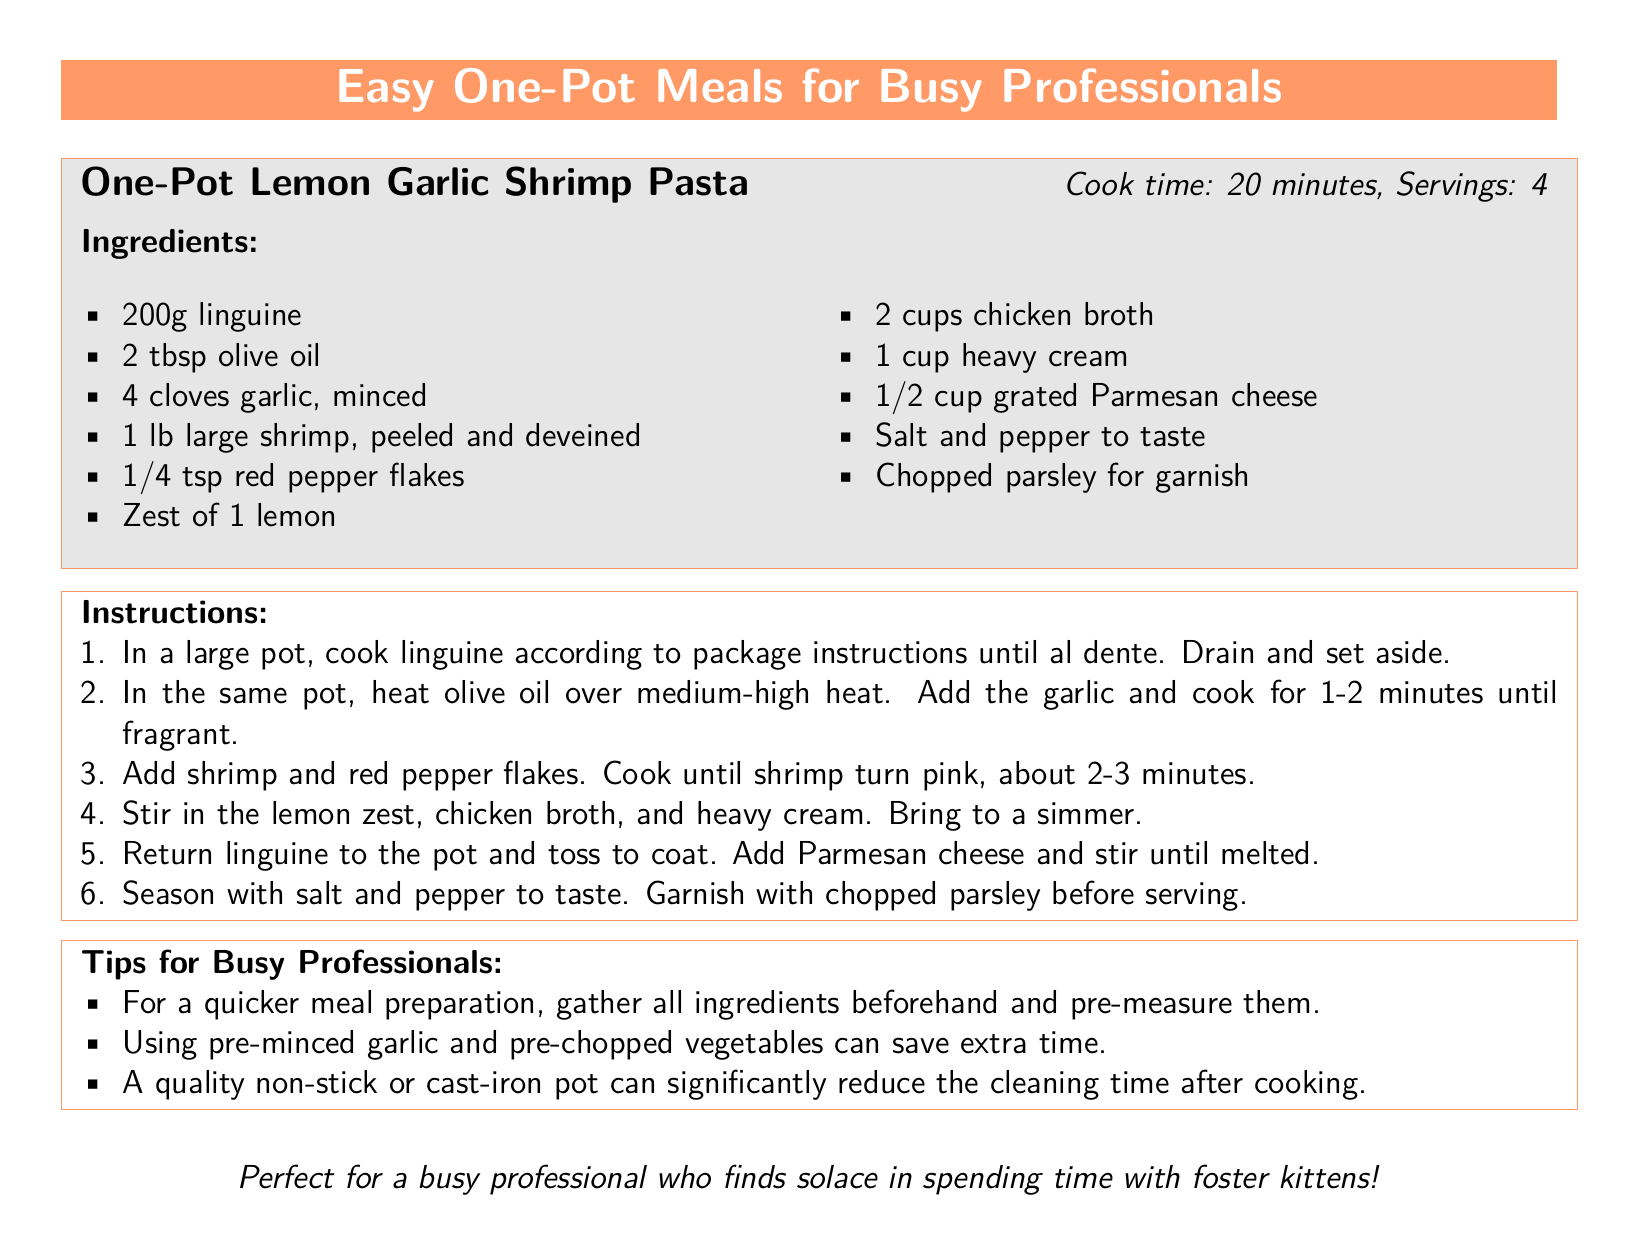What is the cook time for the recipe? The cook time is mentioned in the recipe box for One-Pot Lemon Garlic Shrimp Pasta, which is 20 minutes.
Answer: 20 minutes How many servings does the recipe yield? The number of servings is included in the recipe box, indicating that it serves four.
Answer: 4 What key ingredient is used for flavoring in the recipe? The key ingredient used for flavoring in the recipe is garlic, as stated in the ingredients list.
Answer: Garlic What type of pasta is used in the recipe? The type of pasta is specified in the ingredients list of the recipe as linguine.
Answer: Linguine What is a tip for quicker meal preparation? The document provides a tip for quicker meal preparation, which is to gather and pre-measure all ingredients beforehand.
Answer: Pre-measure ingredients How many cloves of garlic are needed for the recipe? The number of cloves of garlic required is explicitly mentioned in the ingredients list, which is four cloves.
Answer: 4 cloves What should be done to the shrimp before adding it to the pot? The document specifies that the shrimp should be peeled and deveined before cooking.
Answer: Peeled and deveined What can reduce cleaning time after cooking? The document suggests that using a quality non-stick or cast-iron pot can significantly reduce cleaning time after cooking.
Answer: Non-stick or cast-iron pot 